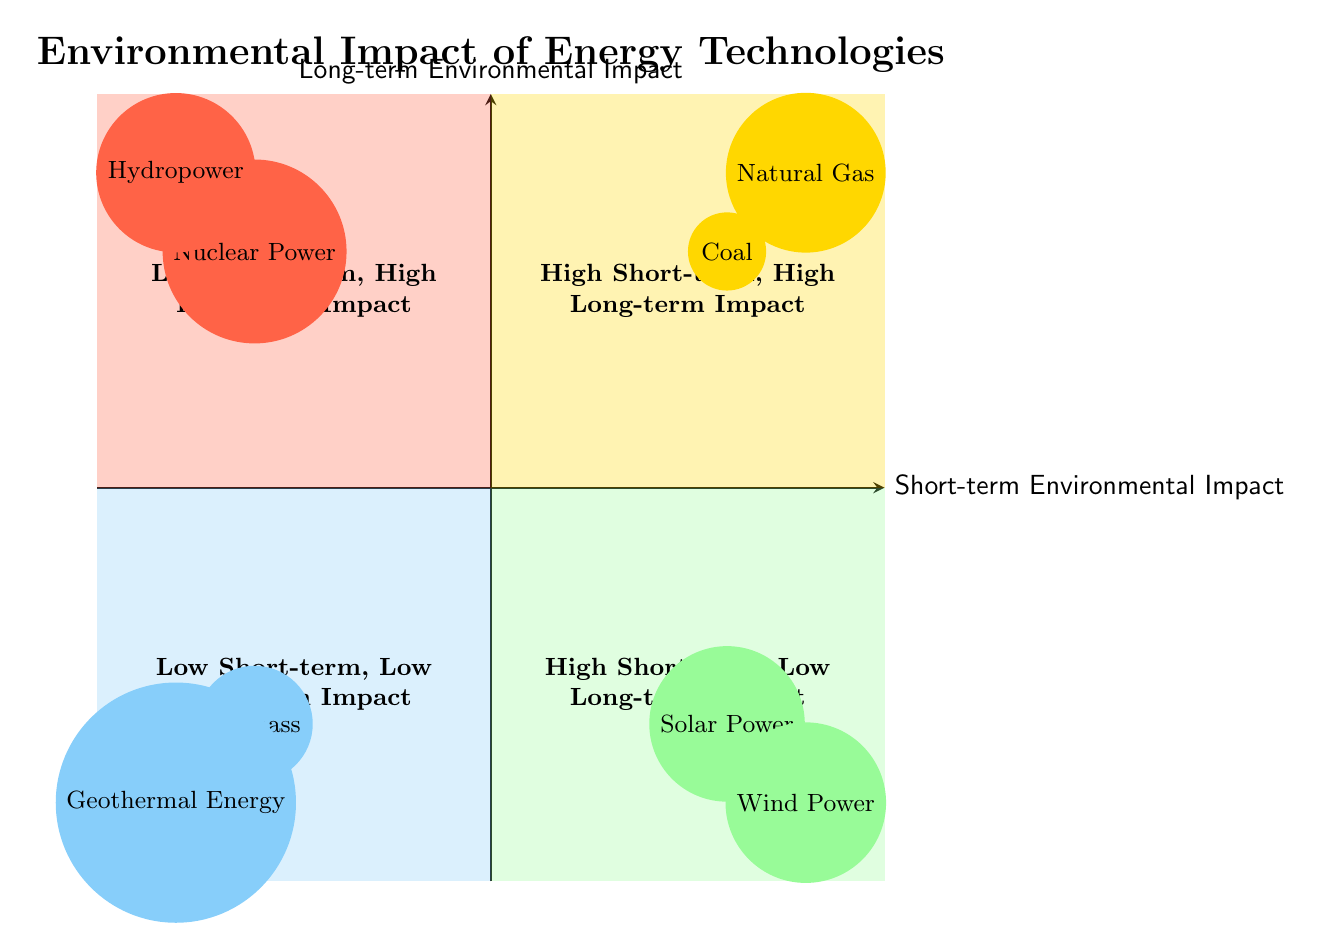What technologies are in the Low Short-term, High Long-term Impact quadrant? The Low Short-term, High Long-term Impact quadrant contains the technologies "Nuclear Power" and "Hydropower." These are visually placed in the top left section of the quadrant chart.
Answer: Nuclear Power, Hydropower How many technologies are in the High Short-term, High Long-term Impact quadrant? There are two technologies in the High Short-term, High Long-term Impact quadrant, which are "Coal" and "Natural Gas," located in the top right area of the diagram.
Answer: 2 Which quadrant contains Solar Power? Solar Power is located in the Low Short-term, Low Long-term Impact quadrant, which is the bottom right section of the quadrant chart.
Answer: Low Short-term, Low Long-term Impact What do the technologies in the quadrant with High Short-term, Low Long-term Impact have in common? The technologies "Biomass" and "Geothermal Energy," found in the High Short-term, Low Long-term Impact quadrant, share the characteristic of having a significant immediate environmental impact but a relatively low long-term impact, indicating they may cause environmental issues but are less harmful over time.
Answer: Significant immediate impact Which technology has the highest potential long-term impact? "Nuclear Power" in the Low Short-term, High Long-term Impact quadrant is considered to have the highest potential long-term environmental impact compared to others, as indicated by its position high on the Y-axis of the diagram.
Answer: Nuclear Power Which two quadrants contain technologies that provide low long-term environmental impact? The Low Short-term, Low Long-term Impact quadrant and the High Short-term, Low Long-term Impact quadrant contain technologies with low long-term environmental impact. The former has "Solar Power" and "Wind Power," while the latter has "Biomass" and "Geothermal Energy."
Answer: Low Short-term, Low Long-term Impact; High Short-term, Low Long-term Impact 